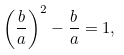Convert formula to latex. <formula><loc_0><loc_0><loc_500><loc_500>\left ( { \frac { b } { a } } \right ) ^ { 2 } - { \frac { b } { a } } = 1 ,</formula> 